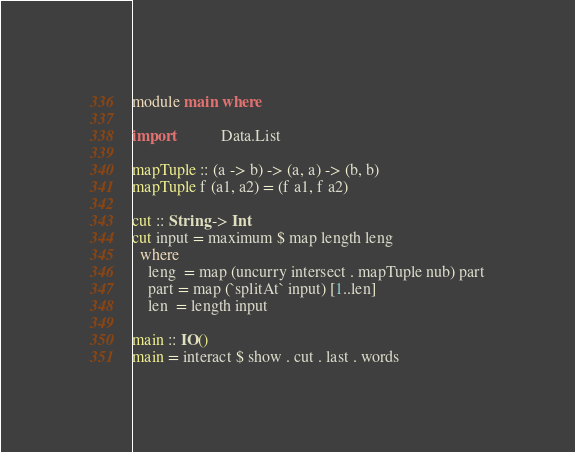<code> <loc_0><loc_0><loc_500><loc_500><_Haskell_>module main where

import           Data.List

mapTuple :: (a -> b) -> (a, a) -> (b, b)
mapTuple f (a1, a2) = (f a1, f a2)

cut :: String -> Int
cut input = maximum $ map length leng
  where
    leng  = map (uncurry intersect . mapTuple nub) part
    part = map (`splitAt` input) [1..len]
    len  = length input

main :: IO()
main = interact $ show . cut . last . words
</code> 